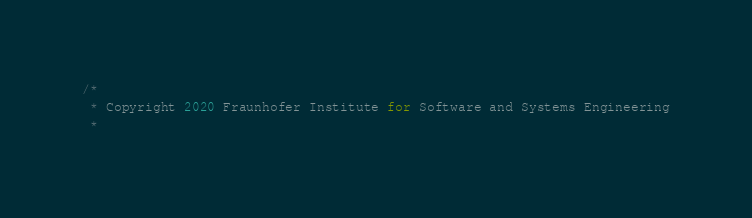<code> <loc_0><loc_0><loc_500><loc_500><_Java_>/*
 * Copyright 2020 Fraunhofer Institute for Software and Systems Engineering
 *</code> 